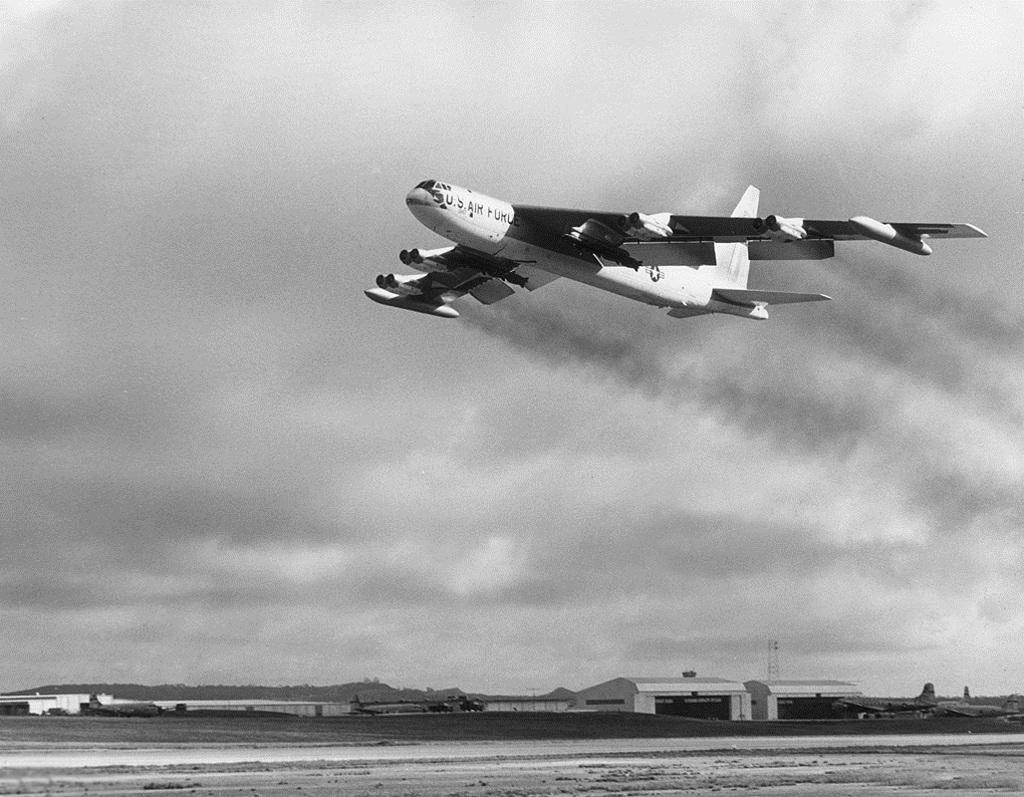<image>
Give a short and clear explanation of the subsequent image. An air plane that reads US Air Force flies in the sky. 